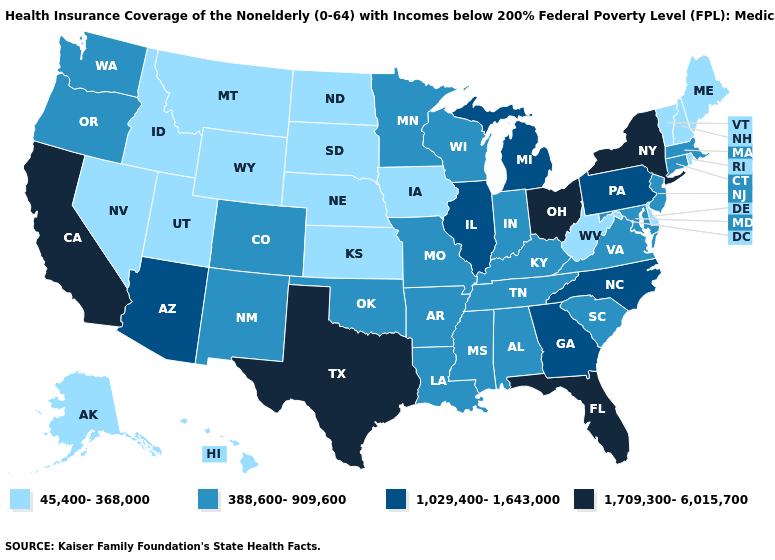Name the states that have a value in the range 1,709,300-6,015,700?
Keep it brief. California, Florida, New York, Ohio, Texas. What is the highest value in states that border New Mexico?
Keep it brief. 1,709,300-6,015,700. Does Iowa have the lowest value in the USA?
Concise answer only. Yes. Name the states that have a value in the range 1,029,400-1,643,000?
Keep it brief. Arizona, Georgia, Illinois, Michigan, North Carolina, Pennsylvania. What is the value of New York?
Give a very brief answer. 1,709,300-6,015,700. What is the highest value in the USA?
Quick response, please. 1,709,300-6,015,700. Name the states that have a value in the range 1,029,400-1,643,000?
Concise answer only. Arizona, Georgia, Illinois, Michigan, North Carolina, Pennsylvania. Among the states that border Alabama , which have the lowest value?
Write a very short answer. Mississippi, Tennessee. Name the states that have a value in the range 45,400-368,000?
Write a very short answer. Alaska, Delaware, Hawaii, Idaho, Iowa, Kansas, Maine, Montana, Nebraska, Nevada, New Hampshire, North Dakota, Rhode Island, South Dakota, Utah, Vermont, West Virginia, Wyoming. What is the highest value in the Northeast ?
Be succinct. 1,709,300-6,015,700. Among the states that border Minnesota , which have the lowest value?
Concise answer only. Iowa, North Dakota, South Dakota. Does Virginia have the lowest value in the South?
Write a very short answer. No. What is the highest value in the USA?
Short answer required. 1,709,300-6,015,700. Does Utah have the lowest value in the USA?
Give a very brief answer. Yes. Name the states that have a value in the range 1,029,400-1,643,000?
Be succinct. Arizona, Georgia, Illinois, Michigan, North Carolina, Pennsylvania. 